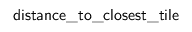Convert formula to latex. <formula><loc_0><loc_0><loc_500><loc_500>d i s t a n c e \_ t o \_ c l o s e s t \_ t i l e</formula> 